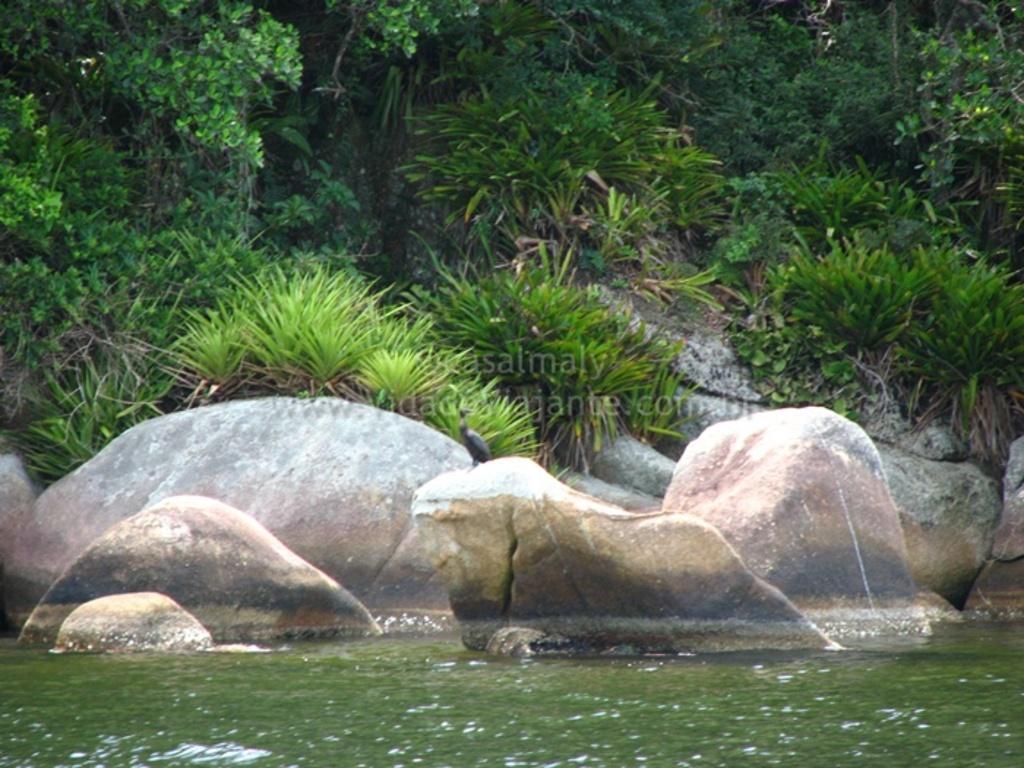Can you describe this image briefly? In this image there is water at the bottom, Beside the water there are rocks. In the middle there is a bird sitting on the rock. In the background there are plants and trees. 